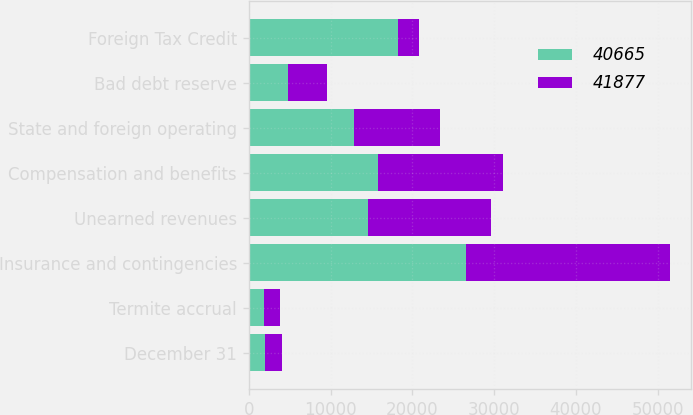Convert chart. <chart><loc_0><loc_0><loc_500><loc_500><stacked_bar_chart><ecel><fcel>December 31<fcel>Termite accrual<fcel>Insurance and contingencies<fcel>Unearned revenues<fcel>Compensation and benefits<fcel>State and foreign operating<fcel>Bad debt reserve<fcel>Foreign Tax Credit<nl><fcel>40665<fcel>2016<fcel>1848<fcel>26560<fcel>14610<fcel>15798<fcel>12817<fcel>4842<fcel>18213<nl><fcel>41877<fcel>2015<fcel>1968<fcel>24991<fcel>15026<fcel>15288<fcel>10629<fcel>4779<fcel>2554<nl></chart> 